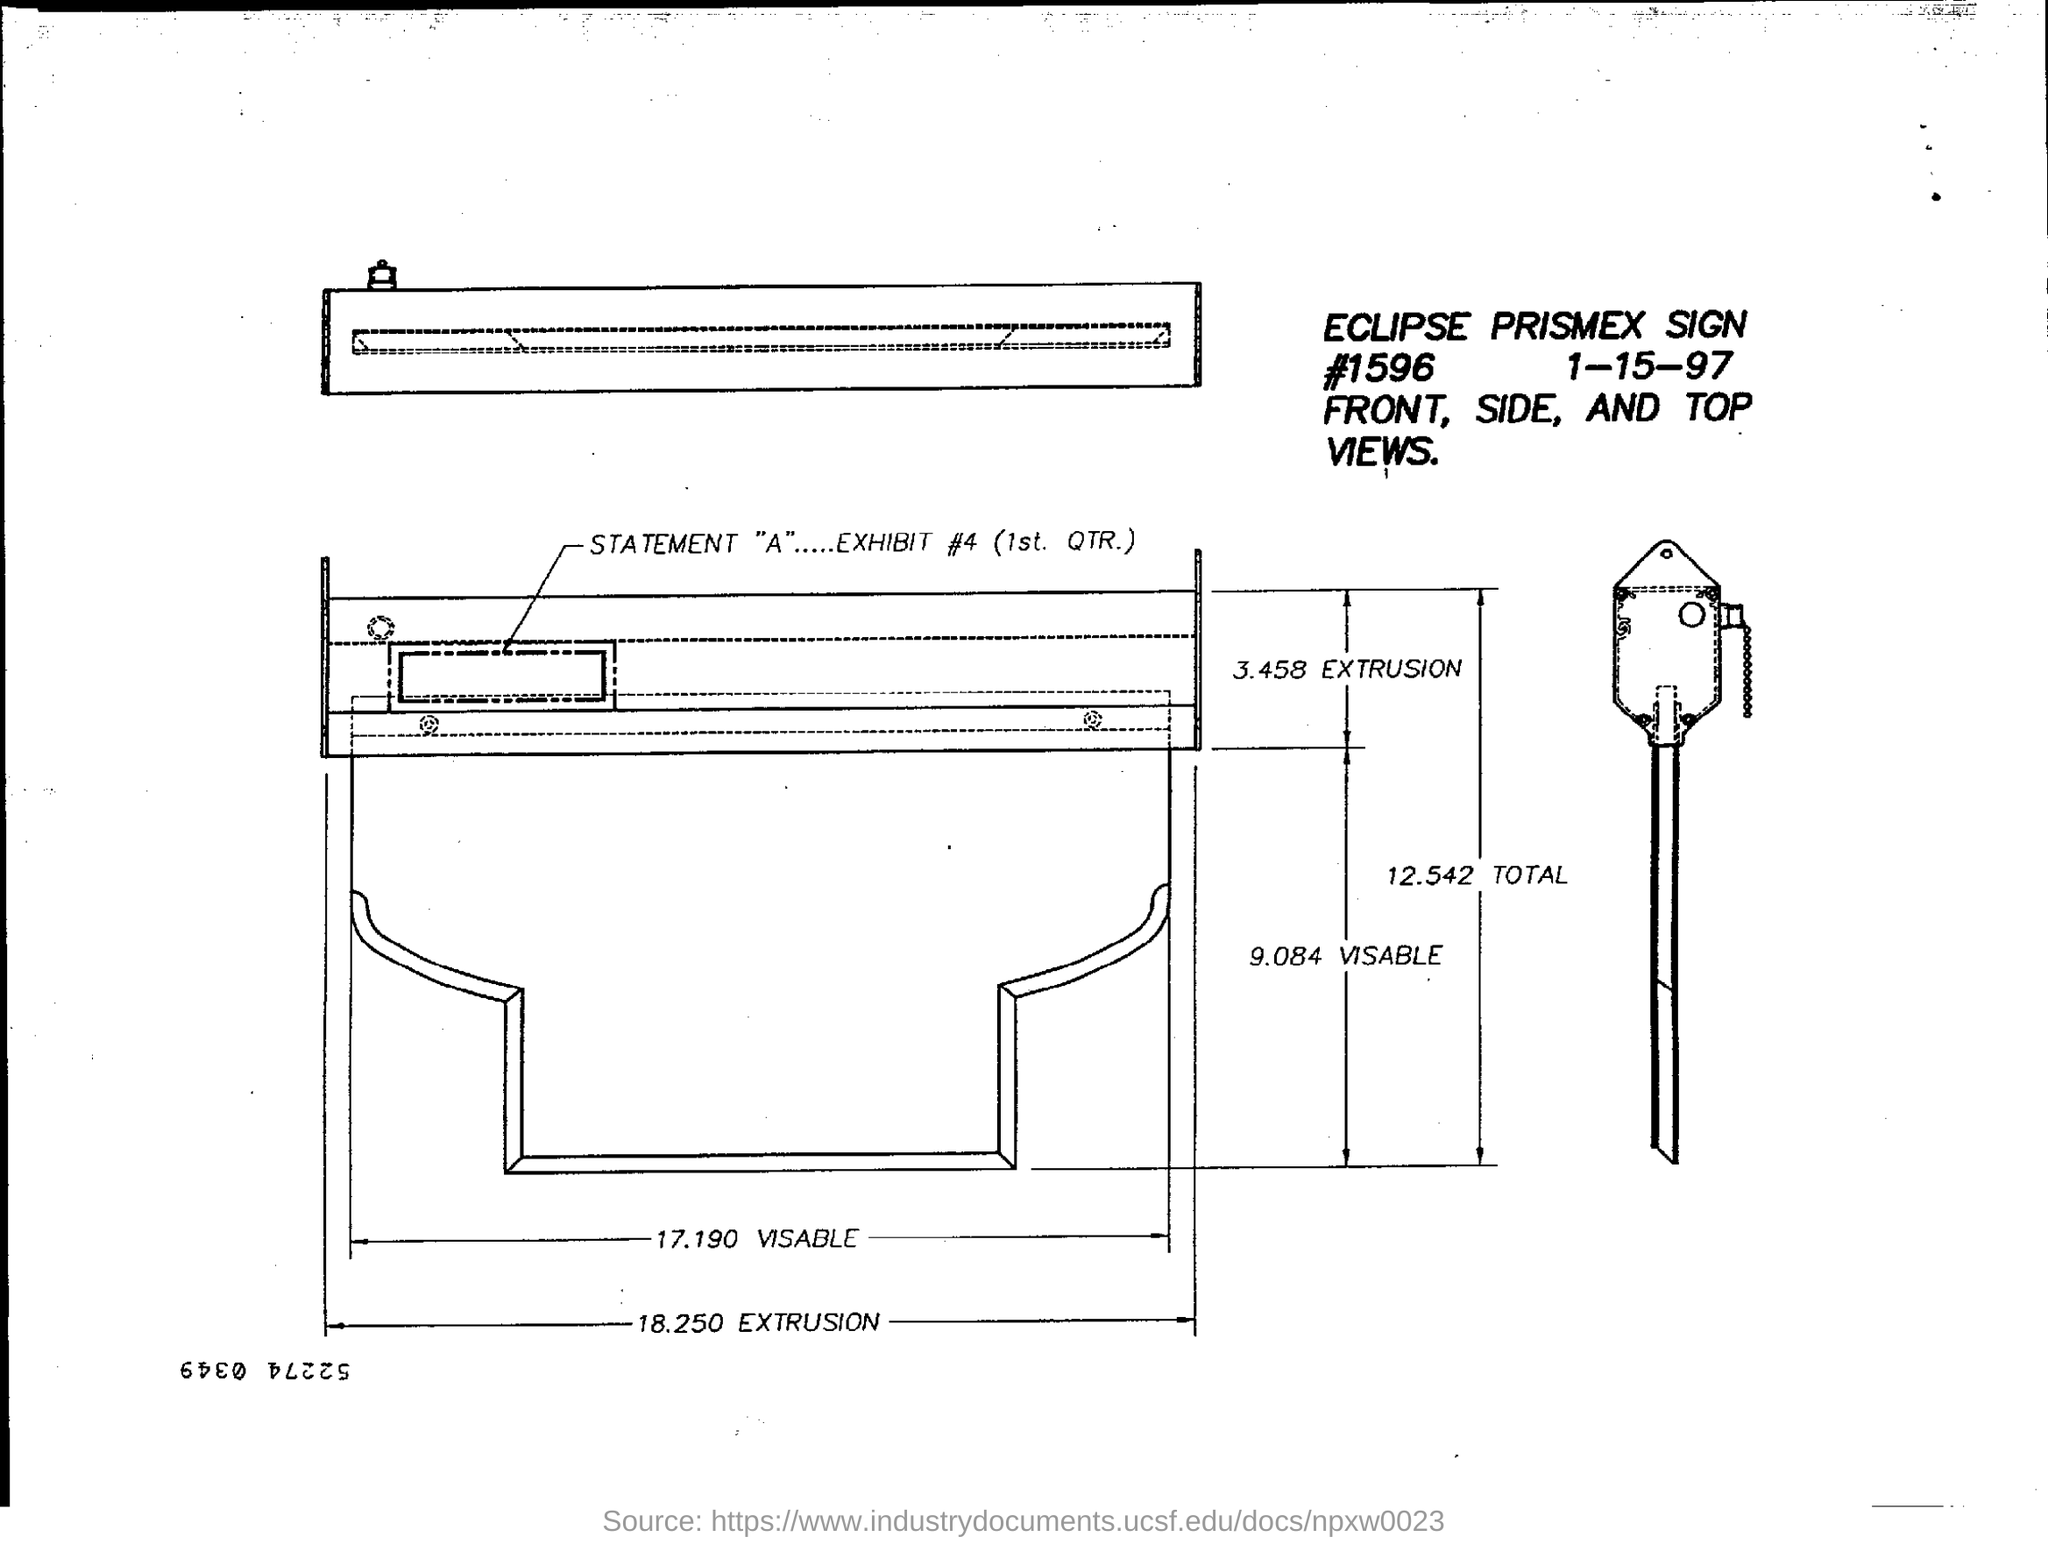What is the exhibit #?
Offer a very short reply. EXHIBIT #4 (1st. QTR.). 